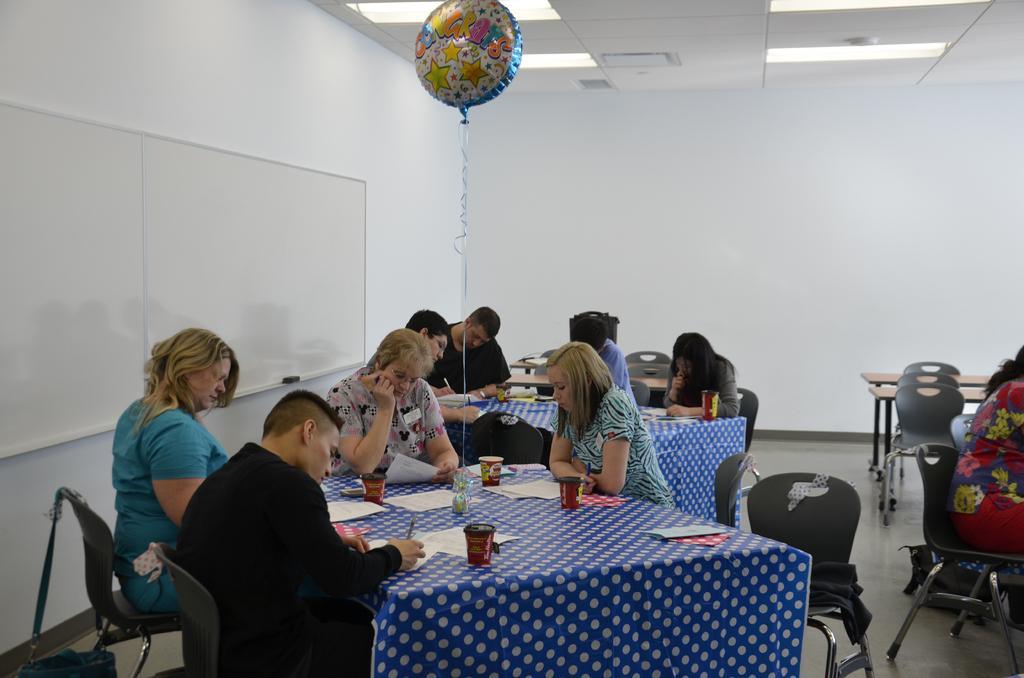How would you summarize this image in a sentence or two? It seems to be the image is inside the room. In the image there are group of people sitting on chair as in front of a table, on table we can see a glass,paper,pen. On left side we can see a white color board, in background there is a white color wall on top there is a roof with few lights and a balloon. 